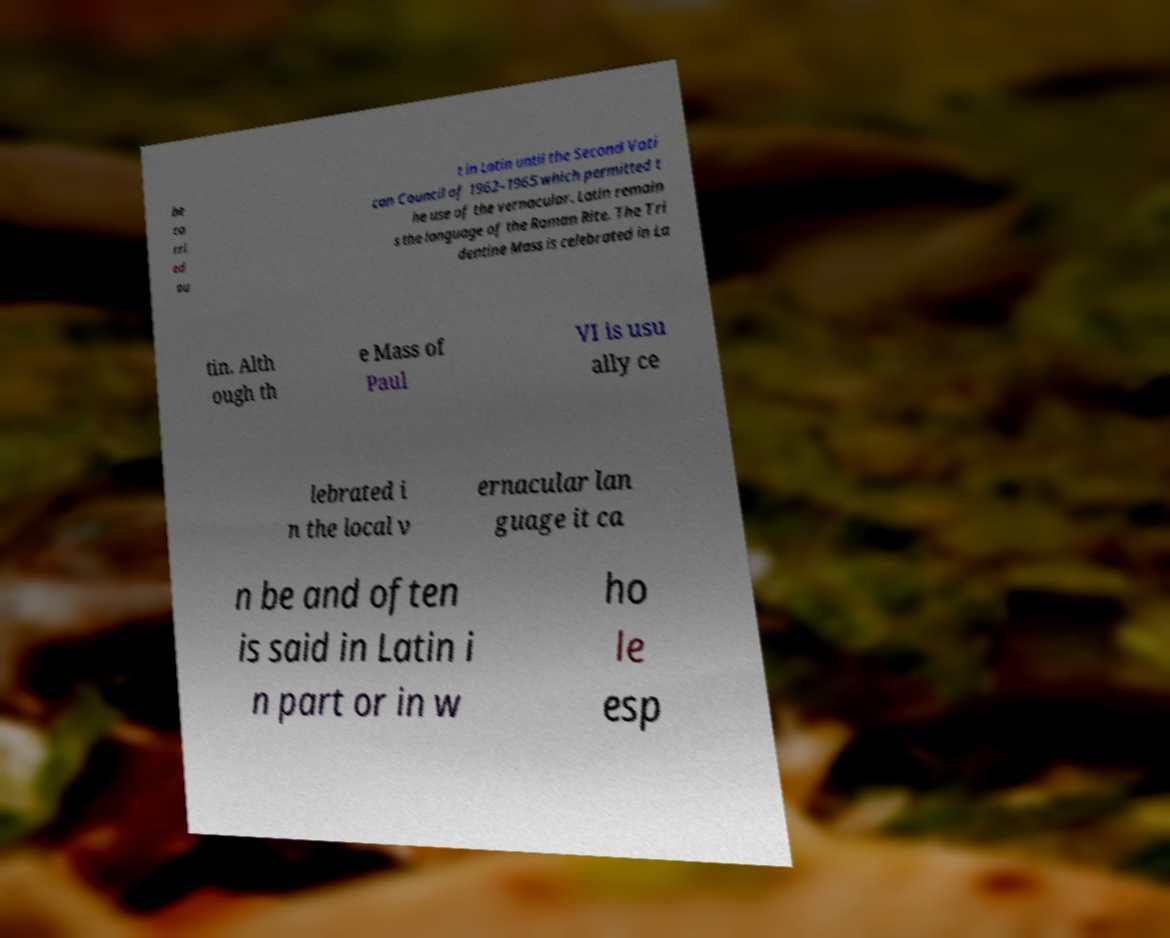Could you extract and type out the text from this image? be ca rri ed ou t in Latin until the Second Vati can Council of 1962–1965 which permitted t he use of the vernacular. Latin remain s the language of the Roman Rite. The Tri dentine Mass is celebrated in La tin. Alth ough th e Mass of Paul VI is usu ally ce lebrated i n the local v ernacular lan guage it ca n be and often is said in Latin i n part or in w ho le esp 